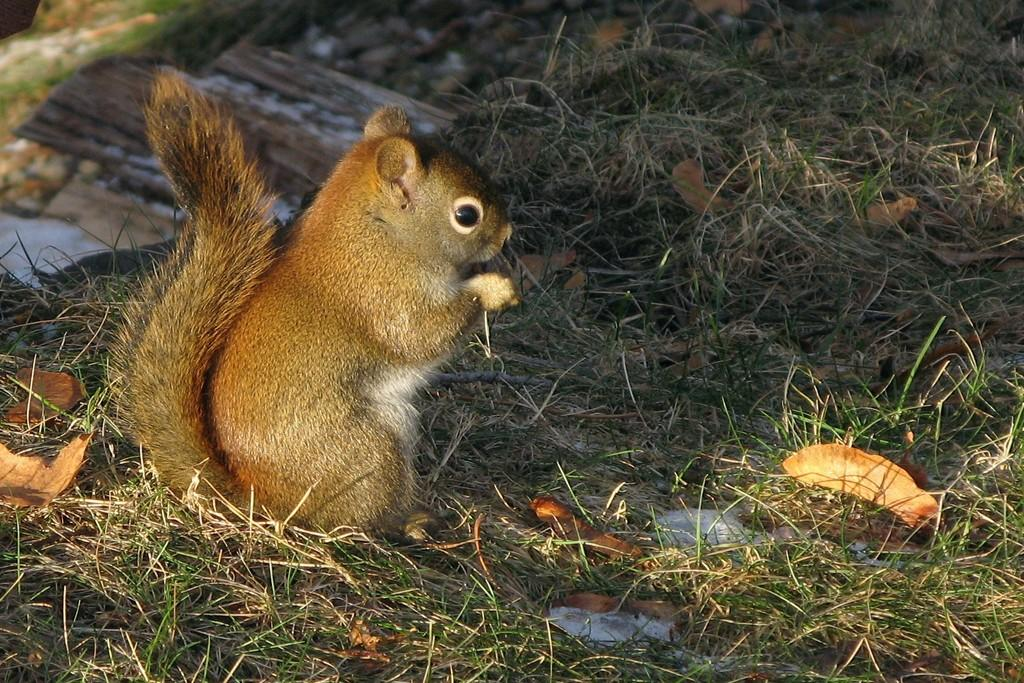What type of animal is on the left side of the image? The animal's specific type is not mentioned, but it is present on the left side of the image. Where is the animal located in the image? The animal is in the grass. What is the condition of the grass in the image? The grass has dry leaves on it. What can be seen in the background of the image? There is grass visible in the background of the image. What type of alley can be seen in the image? There is no alley present in the image; it features an animal in the grass with dry leaves. 